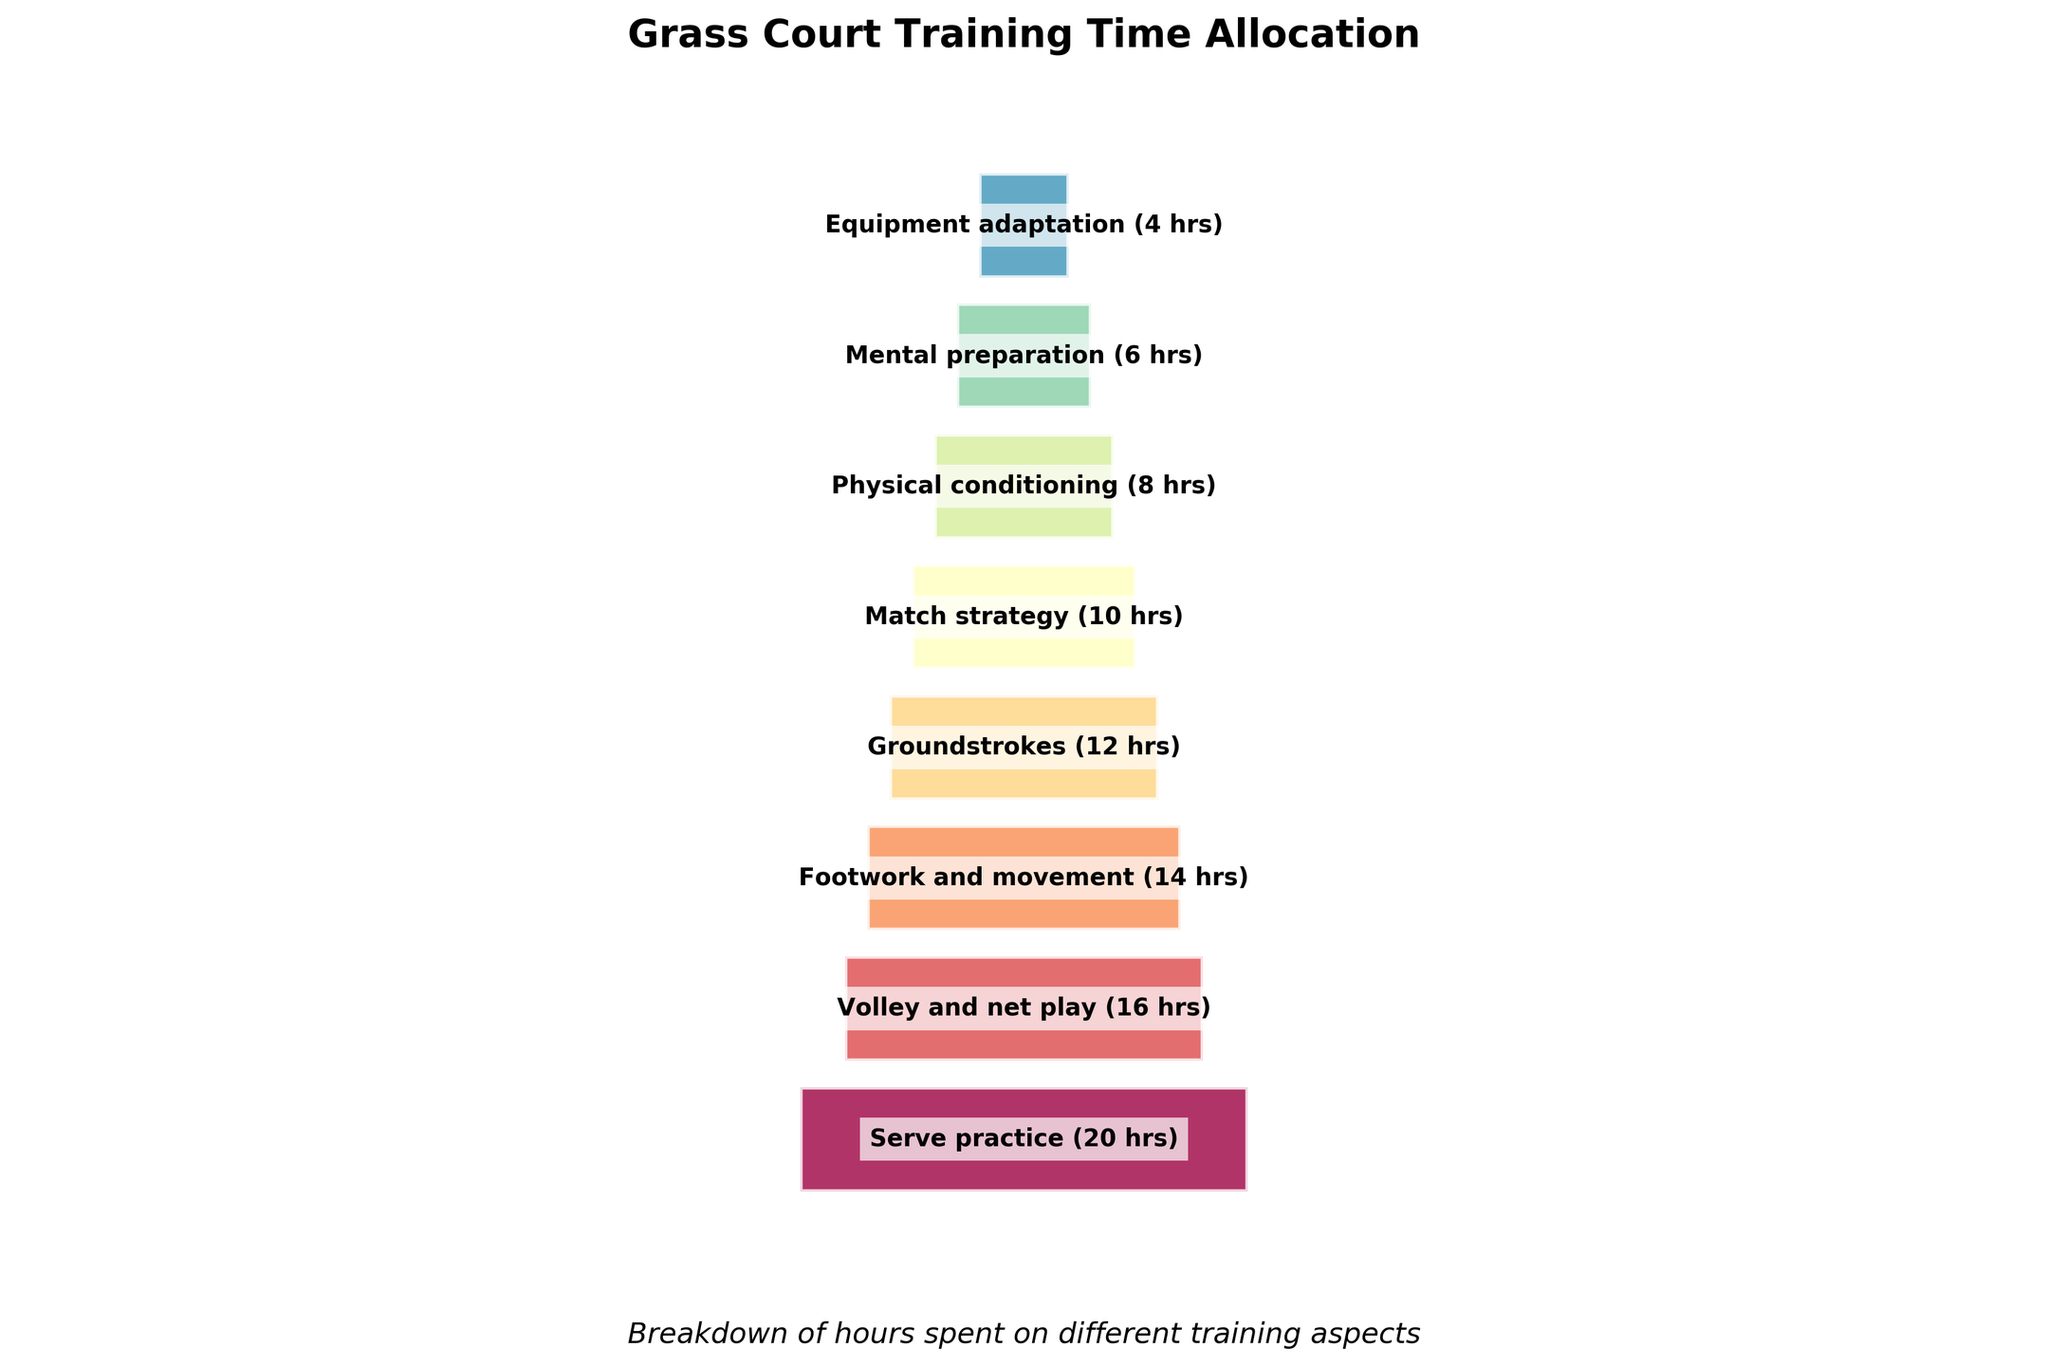How many different training activities are listed in the figure? Count the total number of different segments/activities in the funnel chart.
Answer: 8 Which training activity occupies the largest segment in the funnel chart? Identify the segment with the greatest width in the chart. It represents the activity that takes up the most hours.
Answer: Serve practice What is the total number of hours allocated to physical conditioning and mental preparation combined? Add the hours assigned to physical conditioning (8 hours) and mental preparation (6 hours).
Answer: 14 hours Which activity has less allocated time: Match strategy or Equipment adaptation? Compare the hours allocated to match strategy (10 hours) and equipment adaptation (4 hours). The one with fewer hours is the answer.
Answer: Equipment adaptation How many activities have more than 10 hours allocated? Identify activities with hours greater than 10 and count them. Serve practice (20), Volley and net play (16), Footwork and movement (14), Groundstrokes (12).
Answer: 4 activities What proportion of the total time is spent on Serve practice? Calculate the proportion of hours spent on Serve practice (20 hours) out of the total hours. Total hours = 90, so the proportion is (20/90) * 100.
Answer: 22.22% How much more time is spent on Volley and net play compared to Mental preparation? Calculate the difference between hours allocated to Volley and net play (16 hours) and Mental preparation (6 hours).
Answer: 10 hours Is more time spent on Groundstrokes or on Match strategy? Compare the hours allocated to Groundstrokes (12 hours) and Match strategy (10 hours).
Answer: Groundstrokes What is the average time spent on physical conditioning, mental preparation, and equipment adaptation? Add the hours allocated to physical conditioning (8), mental preparation (6), and equipment adaptation (4). Total is 18, divide by 3.
Answer: 6 hours Which activity is allocated exactly half the time of Serve practice? Find the activity that has half of Serve practice's 20 hours. Look for the activity with 10 hours in the chart, which is Match strategy.
Answer: Match strategy 